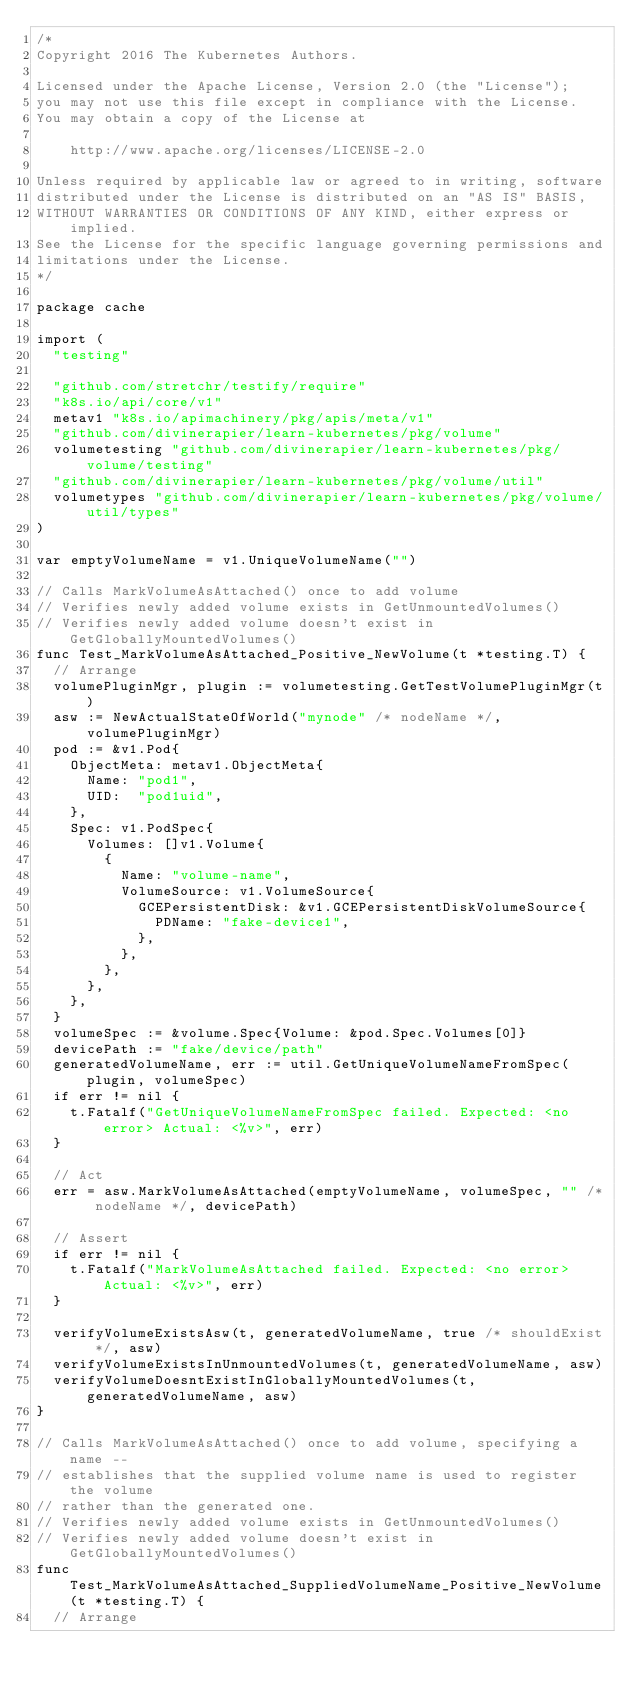<code> <loc_0><loc_0><loc_500><loc_500><_Go_>/*
Copyright 2016 The Kubernetes Authors.

Licensed under the Apache License, Version 2.0 (the "License");
you may not use this file except in compliance with the License.
You may obtain a copy of the License at

    http://www.apache.org/licenses/LICENSE-2.0

Unless required by applicable law or agreed to in writing, software
distributed under the License is distributed on an "AS IS" BASIS,
WITHOUT WARRANTIES OR CONDITIONS OF ANY KIND, either express or implied.
See the License for the specific language governing permissions and
limitations under the License.
*/

package cache

import (
	"testing"

	"github.com/stretchr/testify/require"
	"k8s.io/api/core/v1"
	metav1 "k8s.io/apimachinery/pkg/apis/meta/v1"
	"github.com/divinerapier/learn-kubernetes/pkg/volume"
	volumetesting "github.com/divinerapier/learn-kubernetes/pkg/volume/testing"
	"github.com/divinerapier/learn-kubernetes/pkg/volume/util"
	volumetypes "github.com/divinerapier/learn-kubernetes/pkg/volume/util/types"
)

var emptyVolumeName = v1.UniqueVolumeName("")

// Calls MarkVolumeAsAttached() once to add volume
// Verifies newly added volume exists in GetUnmountedVolumes()
// Verifies newly added volume doesn't exist in GetGloballyMountedVolumes()
func Test_MarkVolumeAsAttached_Positive_NewVolume(t *testing.T) {
	// Arrange
	volumePluginMgr, plugin := volumetesting.GetTestVolumePluginMgr(t)
	asw := NewActualStateOfWorld("mynode" /* nodeName */, volumePluginMgr)
	pod := &v1.Pod{
		ObjectMeta: metav1.ObjectMeta{
			Name: "pod1",
			UID:  "pod1uid",
		},
		Spec: v1.PodSpec{
			Volumes: []v1.Volume{
				{
					Name: "volume-name",
					VolumeSource: v1.VolumeSource{
						GCEPersistentDisk: &v1.GCEPersistentDiskVolumeSource{
							PDName: "fake-device1",
						},
					},
				},
			},
		},
	}
	volumeSpec := &volume.Spec{Volume: &pod.Spec.Volumes[0]}
	devicePath := "fake/device/path"
	generatedVolumeName, err := util.GetUniqueVolumeNameFromSpec(plugin, volumeSpec)
	if err != nil {
		t.Fatalf("GetUniqueVolumeNameFromSpec failed. Expected: <no error> Actual: <%v>", err)
	}

	// Act
	err = asw.MarkVolumeAsAttached(emptyVolumeName, volumeSpec, "" /* nodeName */, devicePath)

	// Assert
	if err != nil {
		t.Fatalf("MarkVolumeAsAttached failed. Expected: <no error> Actual: <%v>", err)
	}

	verifyVolumeExistsAsw(t, generatedVolumeName, true /* shouldExist */, asw)
	verifyVolumeExistsInUnmountedVolumes(t, generatedVolumeName, asw)
	verifyVolumeDoesntExistInGloballyMountedVolumes(t, generatedVolumeName, asw)
}

// Calls MarkVolumeAsAttached() once to add volume, specifying a name --
// establishes that the supplied volume name is used to register the volume
// rather than the generated one.
// Verifies newly added volume exists in GetUnmountedVolumes()
// Verifies newly added volume doesn't exist in GetGloballyMountedVolumes()
func Test_MarkVolumeAsAttached_SuppliedVolumeName_Positive_NewVolume(t *testing.T) {
	// Arrange</code> 